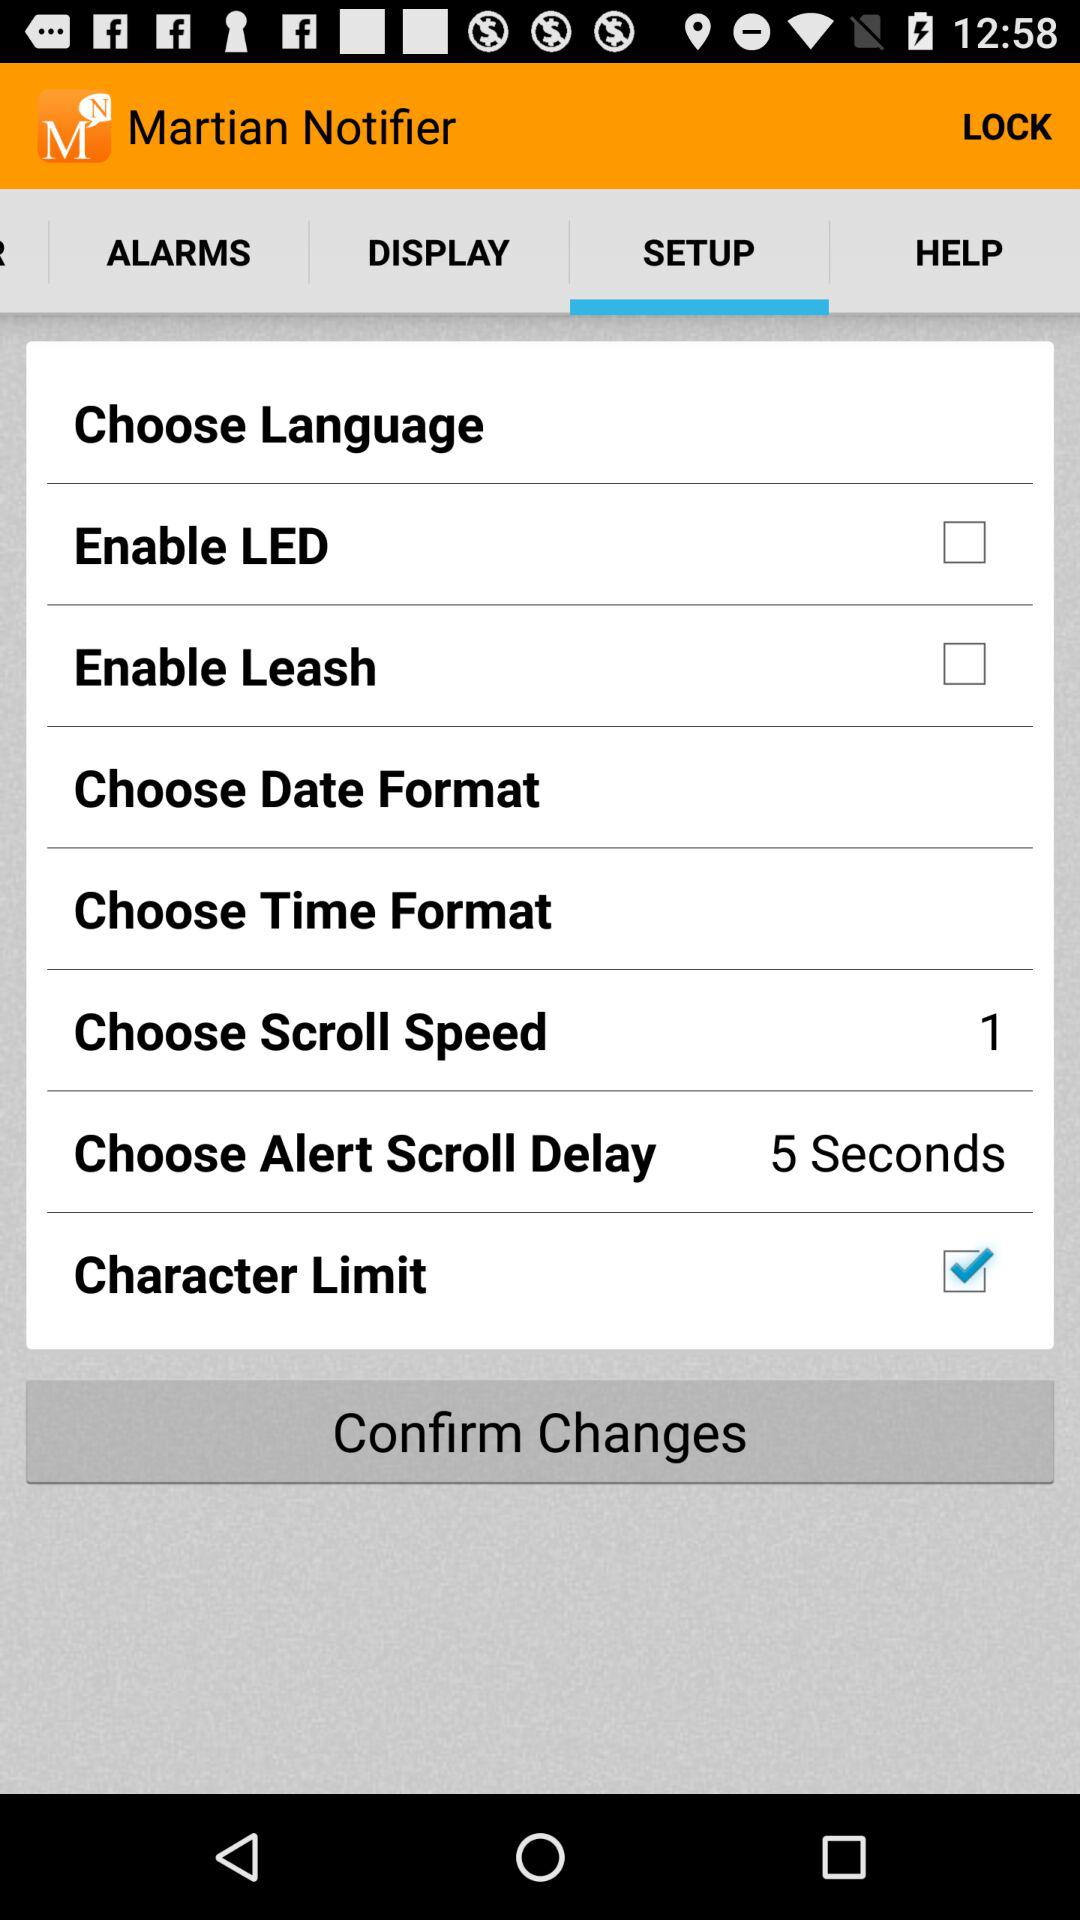How many seconds are selected to choose scroll speed? To choose scroll speed,1 second is selected. 